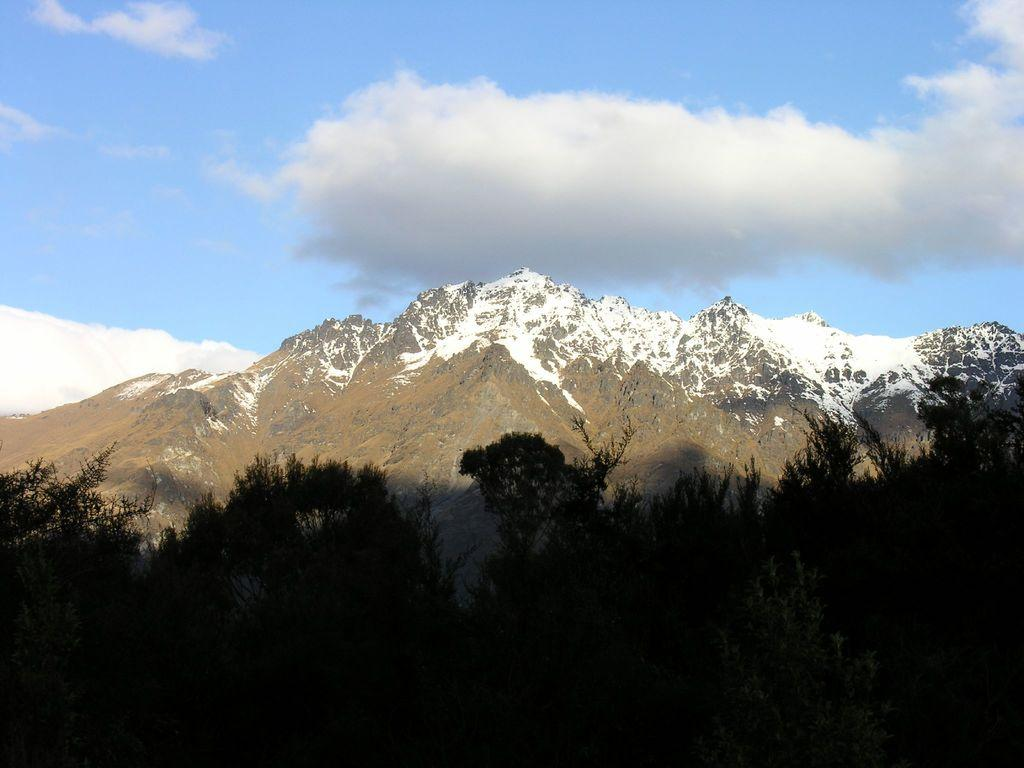What type of vegetation can be seen in the image? There are trees in the image. What geographical feature is covered with snow in the image? There is a mountain covered with snow in the image. What can be seen in the sky at the top of the image? Clouds are visible in the sky at the top of the image. What type of drink is being served at the base of the mountain in the image? There is no drink or indication of any activity at the base of the mountain in the image. What is the elbow's role in the image? There is no mention of an elbow or any body part in the image. 